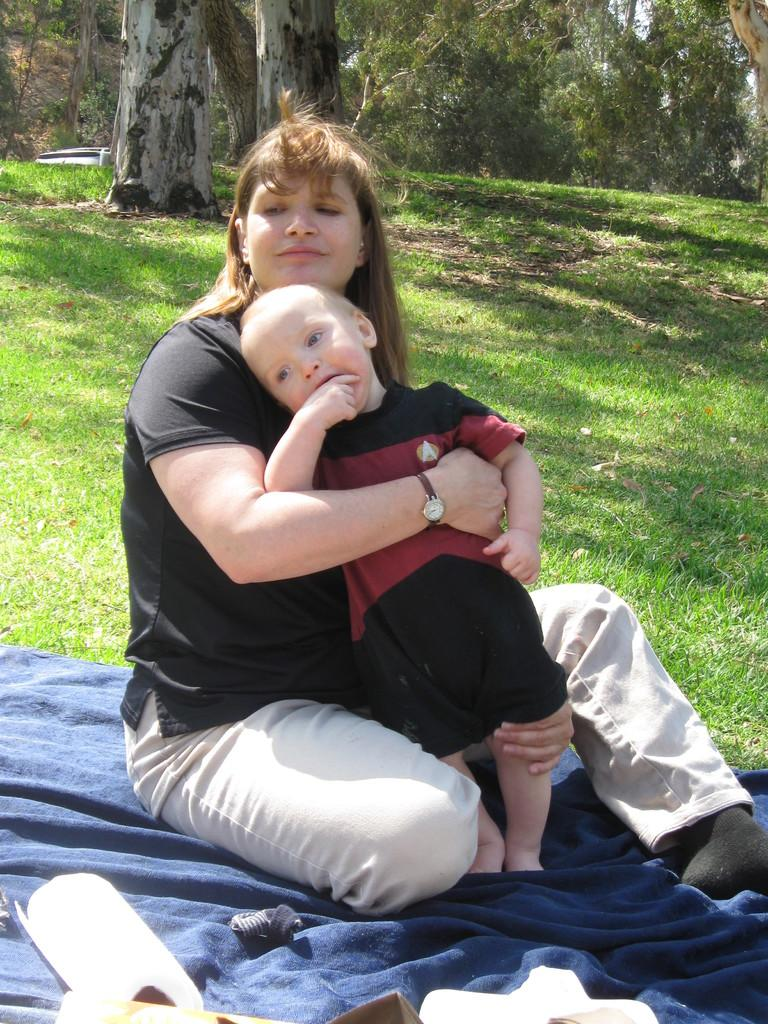Who is the main subject in the image? There is a woman in the image. What is the woman wearing? The woman is wearing black clothing. What is the woman sitting on? The woman is sitting on a blue cloth. Where is the blue cloth located? The blue cloth is on a greenery ground. What is the woman doing in the image? The woman is holding a kid in her hands. What can be seen in the background of the image? There are trees in the background of the image. What type of box is visible in the image? There is no box present in the image. What is the size of the floor in the image? There is no floor visible in the image, as the woman is sitting on a blue cloth on a greenery ground. 